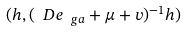<formula> <loc_0><loc_0><loc_500><loc_500>( h , ( \ D e _ { \ g a } + \mu + v ) ^ { - 1 } h )</formula> 